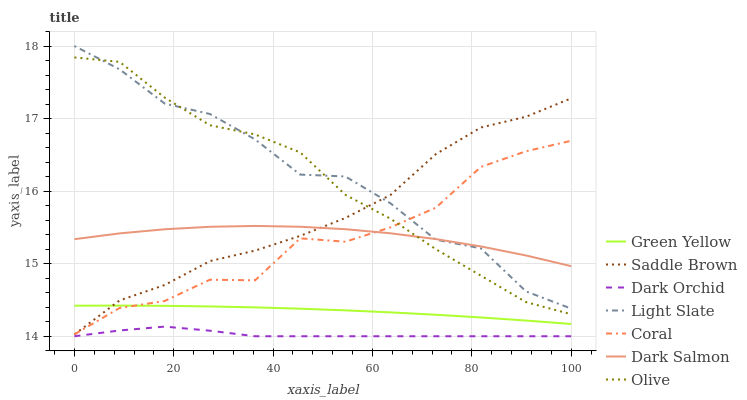Does Dark Orchid have the minimum area under the curve?
Answer yes or no. Yes. Does Light Slate have the maximum area under the curve?
Answer yes or no. Yes. Does Coral have the minimum area under the curve?
Answer yes or no. No. Does Coral have the maximum area under the curve?
Answer yes or no. No. Is Green Yellow the smoothest?
Answer yes or no. Yes. Is Coral the roughest?
Answer yes or no. Yes. Is Dark Salmon the smoothest?
Answer yes or no. No. Is Dark Salmon the roughest?
Answer yes or no. No. Does Dark Orchid have the lowest value?
Answer yes or no. Yes. Does Coral have the lowest value?
Answer yes or no. No. Does Light Slate have the highest value?
Answer yes or no. Yes. Does Coral have the highest value?
Answer yes or no. No. Is Dark Orchid less than Coral?
Answer yes or no. Yes. Is Dark Salmon greater than Dark Orchid?
Answer yes or no. Yes. Does Coral intersect Dark Salmon?
Answer yes or no. Yes. Is Coral less than Dark Salmon?
Answer yes or no. No. Is Coral greater than Dark Salmon?
Answer yes or no. No. Does Dark Orchid intersect Coral?
Answer yes or no. No. 